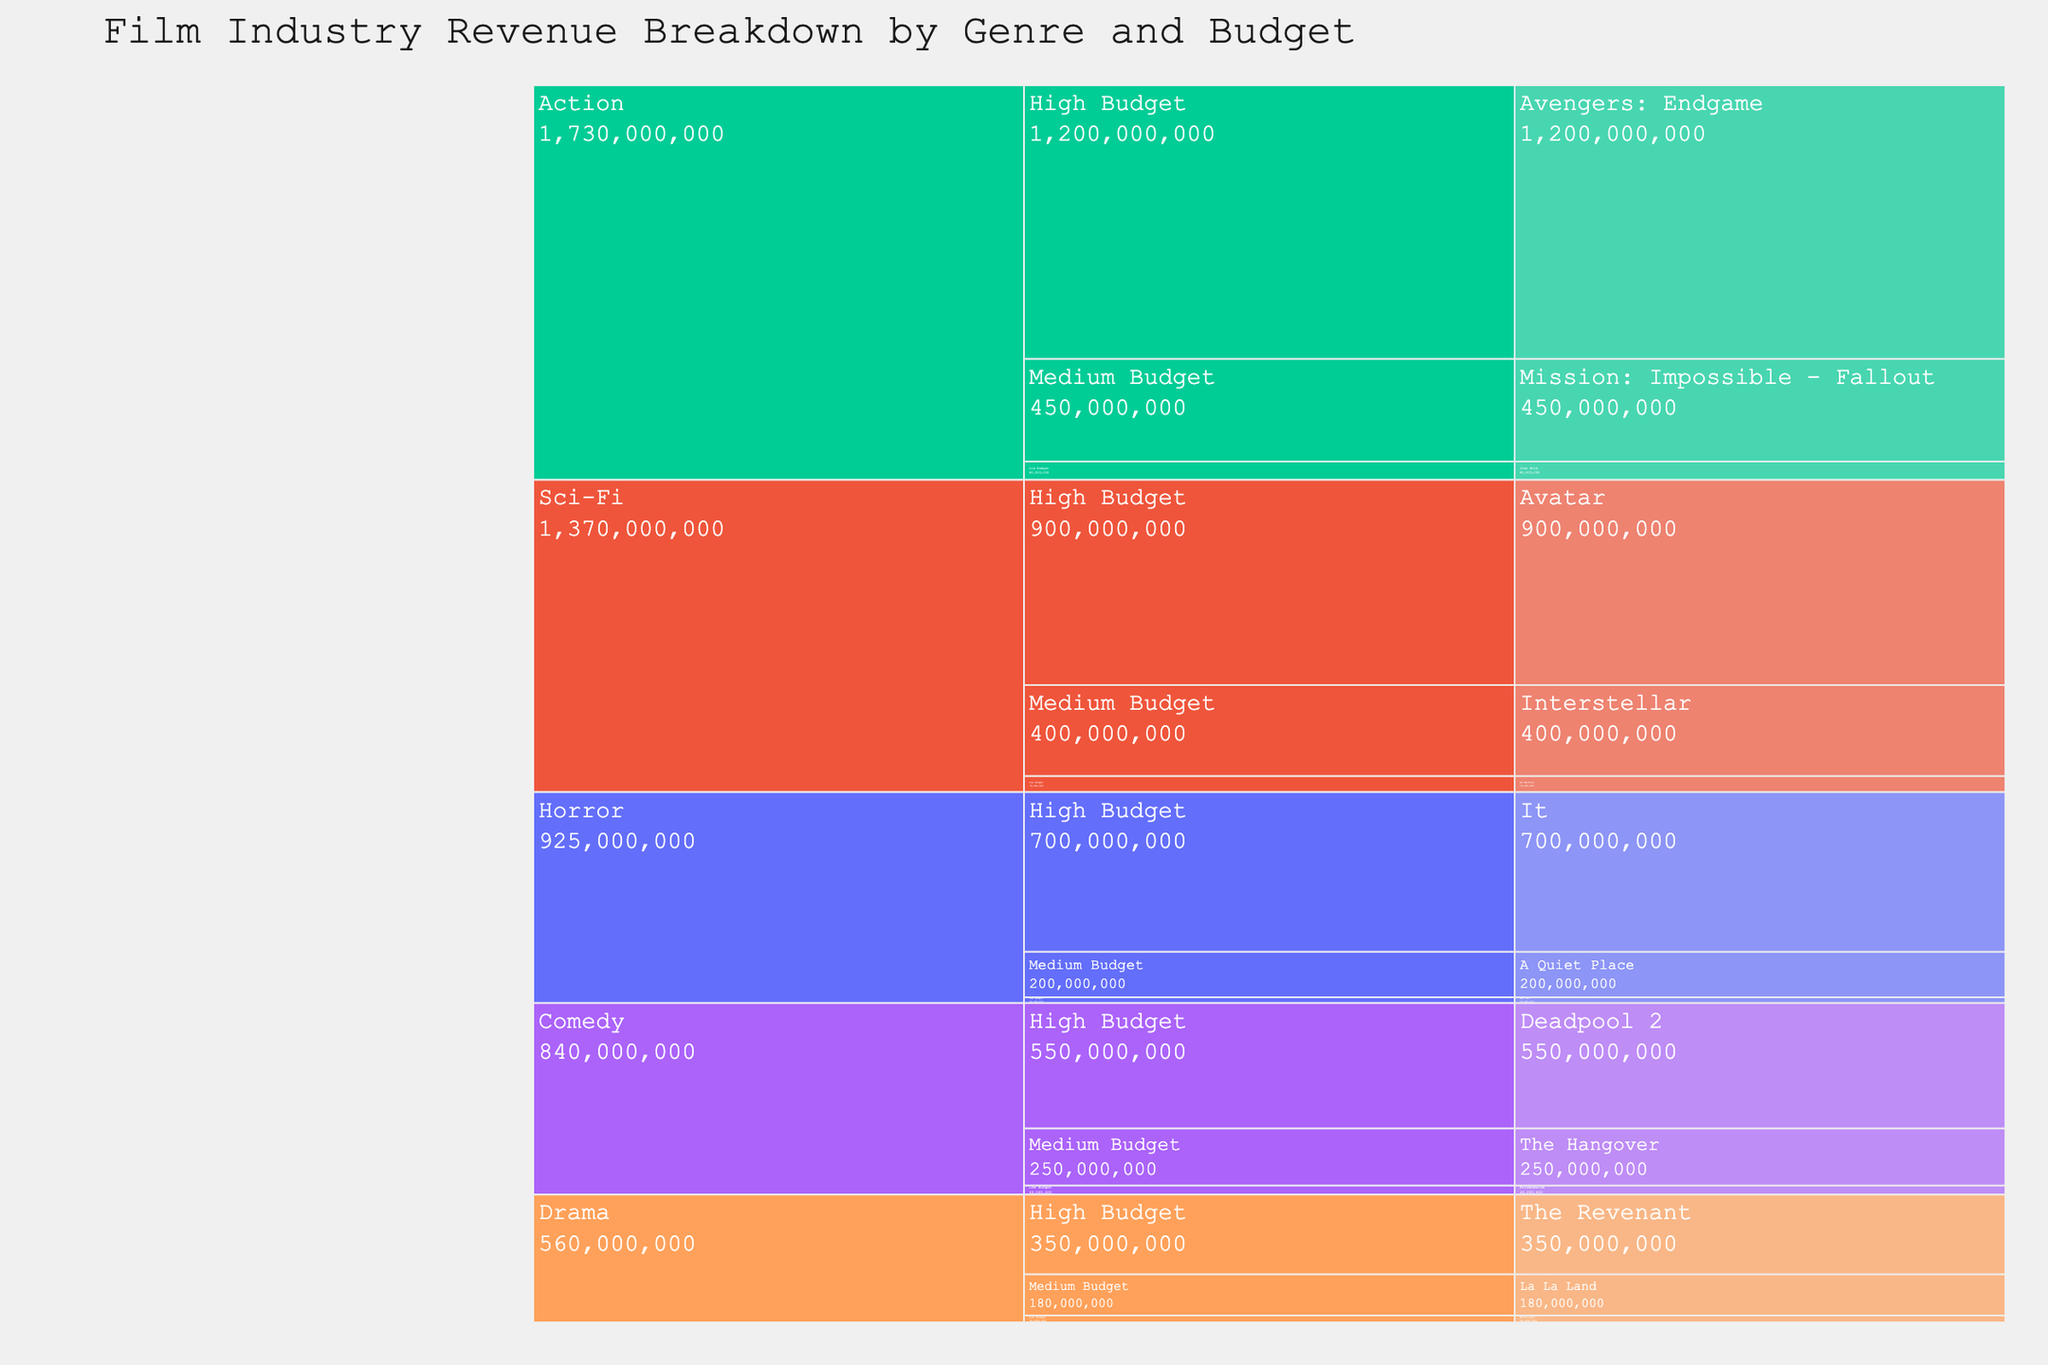What genre has the highest total revenue? Explanation: In the icicle chart, you can identify the total revenue for each genre by looking at the overall size of each genre block. The larger the block, the higher the revenue. From the data, Action has the highest total revenue with its combined values from high, medium, and low budget films.
Answer: Action Which low-budget film generated the highest revenue? Explanation: To find this, navigate through the branches of the icicle chart to locate the sections for low-budget films within each genre. Compare the sizes or specific revenue values of the branches for low-budget films. The highest among them is "John Wick" within the Action genre, with a revenue of $80,000,000.
Answer: John Wick How does the revenue of "Interstellar" compare to that of "La La Land"? Explanation: In the icicle chart, find the sections for Sci-Fi and Drama genres, and then find the medium-budget subcategories within both. Interstellar is within medium-budget Sci-Fi, and La La Land is within medium-budget Drama. Compare their values directly: Interstellar has $400,000,000, and La La Land has $180,000,000.
Answer: Interstellar has more revenue What's the combined revenue of all medium-budget films? Explanation: To calculate this, sum the revenue from each medium-budget film visible in the icicle chart across all genres. Medium-budget films include:
Mission: Impossible - Fallout ($450M), The Hangover ($250M), La La Land ($180M), Interstellar ($400M), A Quiet Place ($200M).
When added together: 450M + 250M + 180M + 400M + 200M = 1480M.
Answer: $1,480,000,000 Which genre has the smallest representation in the icicle chart? Explanation: Look at the overall structure of the icicle chart and identify which genre has the smallest combined section size. Calculate the sum of revenues for each genre, and compare them. From the data, Drama has the smallest representation with revenues of $350M (High), $180M (Medium), and $30M (Low). Total = $560M.
Answer: Drama How much more revenue does "Avatar" generate than "The Revenant"? Explanation: Find the high-budget sections for Sci-Fi (Avatar - $900M) and Drama (The Revenant - $350M). Subtract the revenue of The Revenant from Avatar: 900M - 350M = 550M.
Answer: $550,000,000 Which high-budget comedy film has the highest revenue? Explanation: Navigate to the Comedy genre and then to its high-budget subcategory. The high-budget comedy films included are "Deadpool 2" with $550,000,000. As it is the only high-budget comedy film listed, it has the highest revenue in that section.
Answer: Deadpool 2 What's the genre with the highest revenue in the low-budget category? Explanation: Look at the low-budget category for each genre on the icicle chart. Compare the revenues for all low-budget films: John Wick ($80M for Action), Bridesmaids ($40M for Comedy), Moonlight ($30M for Drama), Ex Machina ($70M for Sci-Fi), and Get Out ($25M for Horror). Action (John Wick) generates the highest revenue in the low-budget category with $80M.
Answer: Action Which film has a higher revenue: "It" or "Mission: Impossible - Fallout"? Explanation: In the icicle chart, locate the Horror genre for "It" ($700M) and the medium-budget category within Action for "Mission: Impossible - Fallout" ($450M). Compare the values directly: It has a higher revenue.
Answer: It What is the average revenue of all high-budget films in the chart? Explanation: Identify all high-budget films across various genres and sum up their revenues. The high-budget films are:
Avengers: Endgame ($1,200M), Deadpool 2 ($550M), The Revenant ($350M), Avatar ($900M), and It ($700M).
Sum = 1200M + 550M + 350M + 900M + 700M = 3700M.
Number of high-budget films = 5.
Average = 3700M / 5 = 740M.
Answer: $740,000,000 